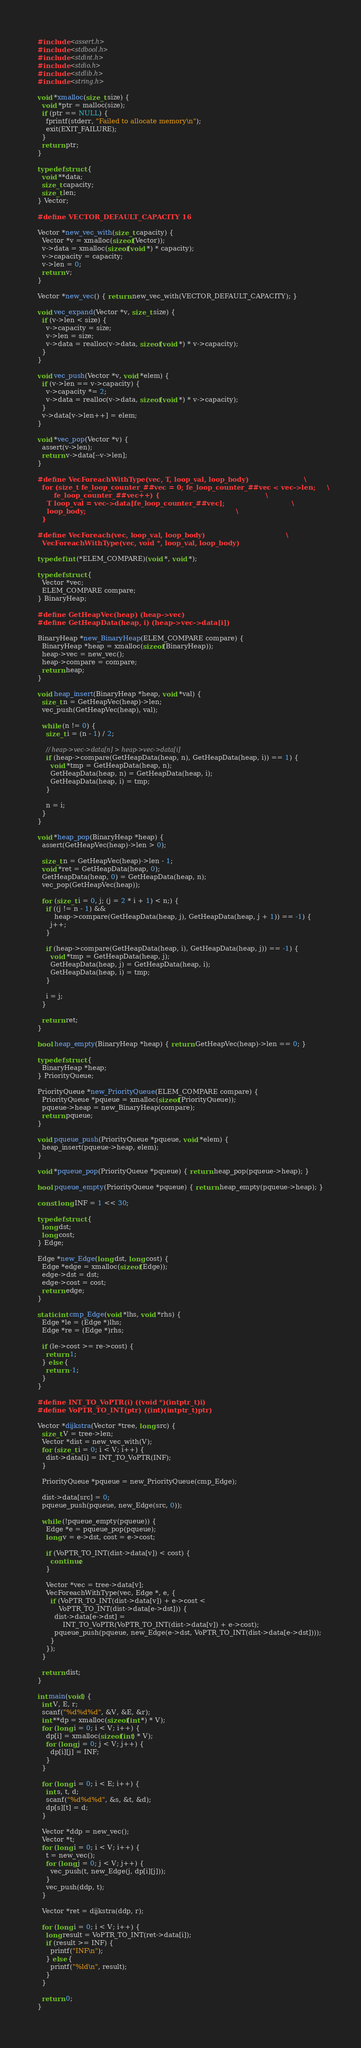Convert code to text. <code><loc_0><loc_0><loc_500><loc_500><_C_>#include <assert.h>
#include <stdbool.h>
#include <stdint.h>
#include <stdio.h>
#include <stdlib.h>
#include <string.h>

void *xmalloc(size_t size) {
  void *ptr = malloc(size);
  if (ptr == NULL) {
    fprintf(stderr, "Failed to allocate memory\n");
    exit(EXIT_FAILURE);
  }
  return ptr;
}

typedef struct {
  void **data;
  size_t capacity;
  size_t len;
} Vector;

#define VECTOR_DEFAULT_CAPACITY 16

Vector *new_vec_with(size_t capacity) {
  Vector *v = xmalloc(sizeof(Vector));
  v->data = xmalloc(sizeof(void *) * capacity);
  v->capacity = capacity;
  v->len = 0;
  return v;
}

Vector *new_vec() { return new_vec_with(VECTOR_DEFAULT_CAPACITY); }

void vec_expand(Vector *v, size_t size) {
  if (v->len < size) {
    v->capacity = size;
    v->len = size;
    v->data = realloc(v->data, sizeof(void *) * v->capacity);
  }
}

void vec_push(Vector *v, void *elem) {
  if (v->len == v->capacity) {
    v->capacity *= 2;
    v->data = realloc(v->data, sizeof(void *) * v->capacity);
  }
  v->data[v->len++] = elem;
}

void *vec_pop(Vector *v) {
  assert(v->len);
  return v->data[--v->len];
}

#define VecForeachWithType(vec, T, loop_val, loop_body)                        \
  for (size_t fe_loop_counter_##vec = 0; fe_loop_counter_##vec < vec->len;     \
       fe_loop_counter_##vec++) {                                              \
    T loop_val = vec->data[fe_loop_counter_##vec];                             \
    loop_body;                                                                 \
  }

#define VecForeach(vec, loop_val, loop_body)                                   \
  VecForeachWithType(vec, void *, loop_val, loop_body)

typedef int (*ELEM_COMPARE)(void *, void *);

typedef struct {
  Vector *vec;
  ELEM_COMPARE compare;
} BinaryHeap;

#define GetHeapVec(heap) (heap->vec)
#define GetHeapData(heap, i) (heap->vec->data[i])

BinaryHeap *new_BinaryHeap(ELEM_COMPARE compare) {
  BinaryHeap *heap = xmalloc(sizeof(BinaryHeap));
  heap->vec = new_vec();
  heap->compare = compare;
  return heap;
}

void heap_insert(BinaryHeap *heap, void *val) {
  size_t n = GetHeapVec(heap)->len;
  vec_push(GetHeapVec(heap), val);

  while (n != 0) {
    size_t i = (n - 1) / 2;

    // heap->vec->data[n] > heap->vec->data[i]
    if (heap->compare(GetHeapData(heap, n), GetHeapData(heap, i)) == 1) {
      void *tmp = GetHeapData(heap, n);
      GetHeapData(heap, n) = GetHeapData(heap, i);
      GetHeapData(heap, i) = tmp;
    }

    n = i;
  }
}

void *heap_pop(BinaryHeap *heap) {
  assert(GetHeapVec(heap)->len > 0);

  size_t n = GetHeapVec(heap)->len - 1;
  void *ret = GetHeapData(heap, 0);
  GetHeapData(heap, 0) = GetHeapData(heap, n);
  vec_pop(GetHeapVec(heap));

  for (size_t i = 0, j; (j = 2 * i + 1) < n;) {
    if ((j != n - 1) &&
        heap->compare(GetHeapData(heap, j), GetHeapData(heap, j + 1)) == -1) {
      j++;
    }

    if (heap->compare(GetHeapData(heap, i), GetHeapData(heap, j)) == -1) {
      void *tmp = GetHeapData(heap, j);
      GetHeapData(heap, j) = GetHeapData(heap, i);
      GetHeapData(heap, i) = tmp;
    }

    i = j;
  }

  return ret;
}

bool heap_empty(BinaryHeap *heap) { return GetHeapVec(heap)->len == 0; }

typedef struct {
  BinaryHeap *heap;
} PriorityQueue;

PriorityQueue *new_PriorityQueue(ELEM_COMPARE compare) {
  PriorityQueue *pqueue = xmalloc(sizeof(PriorityQueue));
  pqueue->heap = new_BinaryHeap(compare);
  return pqueue;
}

void pqueue_push(PriorityQueue *pqueue, void *elem) {
  heap_insert(pqueue->heap, elem);
}

void *pqueue_pop(PriorityQueue *pqueue) { return heap_pop(pqueue->heap); }

bool pqueue_empty(PriorityQueue *pqueue) { return heap_empty(pqueue->heap); }

const long INF = 1 << 30;

typedef struct {
  long dst;
  long cost;
} Edge;

Edge *new_Edge(long dst, long cost) {
  Edge *edge = xmalloc(sizeof(Edge));
  edge->dst = dst;
  edge->cost = cost;
  return edge;
}

static int cmp_Edge(void *lhs, void *rhs) {
  Edge *le = (Edge *)lhs;
  Edge *re = (Edge *)rhs;

  if (le->cost >= re->cost) {
    return 1;
  } else {
    return -1;
  }
}

#define INT_TO_VoPTR(i) ((void *)(intptr_t)i)
#define VoPTR_TO_INT(ptr) ((int)(intptr_t)ptr)

Vector *dijkstra(Vector *tree, long src) {
  size_t V = tree->len;
  Vector *dist = new_vec_with(V);
  for (size_t i = 0; i < V; i++) {
    dist->data[i] = INT_TO_VoPTR(INF);
  }

  PriorityQueue *pqueue = new_PriorityQueue(cmp_Edge);

  dist->data[src] = 0;
  pqueue_push(pqueue, new_Edge(src, 0));

  while (!pqueue_empty(pqueue)) {
    Edge *e = pqueue_pop(pqueue);
    long v = e->dst, cost = e->cost;

    if (VoPTR_TO_INT(dist->data[v]) < cost) {
      continue;
    }

    Vector *vec = tree->data[v];
    VecForeachWithType(vec, Edge *, e, {
      if (VoPTR_TO_INT(dist->data[v]) + e->cost <
          VoPTR_TO_INT(dist->data[e->dst])) {
        dist->data[e->dst] =
            INT_TO_VoPTR(VoPTR_TO_INT(dist->data[v]) + e->cost);
        pqueue_push(pqueue, new_Edge(e->dst, VoPTR_TO_INT(dist->data[e->dst])));
      }
    });
  }

  return dist;
}

int main(void) {
  int V, E, r;
  scanf("%d%d%d", &V, &E, &r);
  int **dp = xmalloc(sizeof(int *) * V);
  for (long i = 0; i < V; i++) {
    dp[i] = xmalloc(sizeof(int) * V);
    for (long j = 0; j < V; j++) {
      dp[i][j] = INF;
    }
  }

  for (long i = 0; i < E; i++) {
    int s, t, d;
    scanf("%d%d%d", &s, &t, &d);
    dp[s][t] = d;
  }

  Vector *ddp = new_vec();
  Vector *t;
  for (long i = 0; i < V; i++) {
    t = new_vec();
    for (long j = 0; j < V; j++) {
      vec_push(t, new_Edge(j, dp[i][j]));
    }
    vec_push(ddp, t);
  }

  Vector *ret = dijkstra(ddp, r);

  for (long i = 0; i < V; i++) {
    long result = VoPTR_TO_INT(ret->data[i]);
    if (result >= INF) {
      printf("INF\n");
    } else {
      printf("%ld\n", result);
    }
  }

  return 0;
}

</code> 